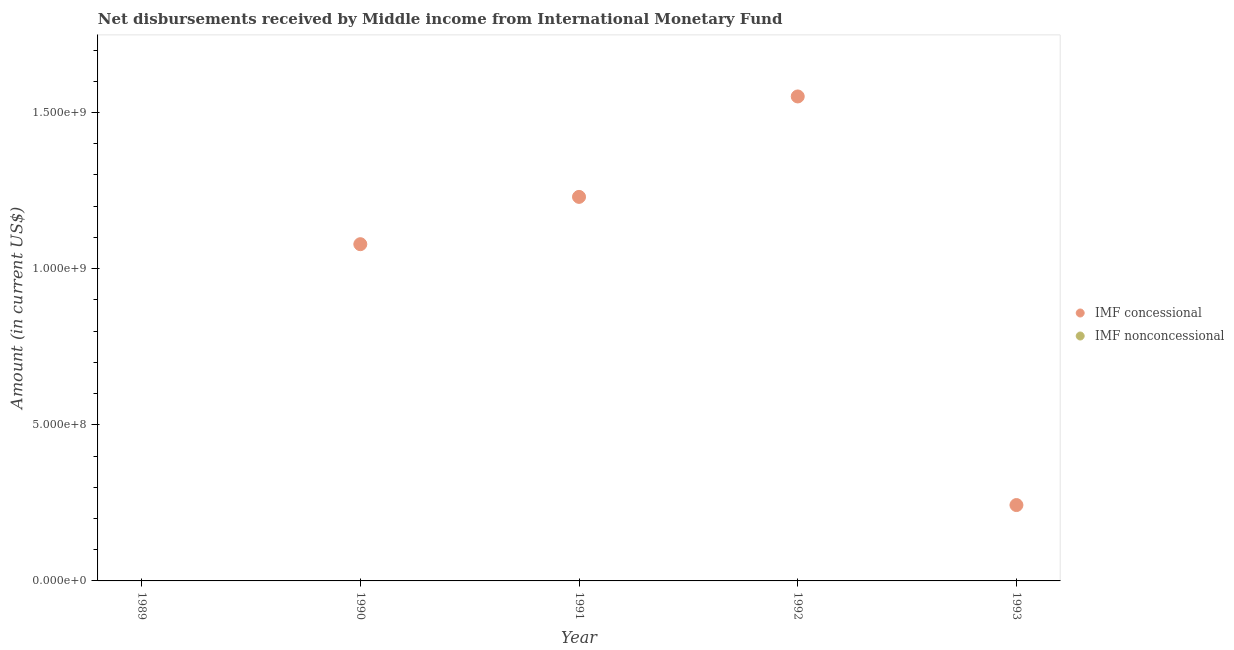Is the number of dotlines equal to the number of legend labels?
Offer a very short reply. No. What is the net non concessional disbursements from imf in 1989?
Your answer should be compact. 0. Across all years, what is the maximum net concessional disbursements from imf?
Provide a succinct answer. 1.55e+09. Across all years, what is the minimum net non concessional disbursements from imf?
Your response must be concise. 0. What is the total net concessional disbursements from imf in the graph?
Offer a terse response. 4.10e+09. What is the difference between the net concessional disbursements from imf in 1991 and that in 1992?
Provide a succinct answer. -3.22e+08. What is the difference between the net concessional disbursements from imf in 1993 and the net non concessional disbursements from imf in 1992?
Your response must be concise. 2.43e+08. What is the average net concessional disbursements from imf per year?
Ensure brevity in your answer.  8.20e+08. In how many years, is the net non concessional disbursements from imf greater than 200000000 US$?
Offer a terse response. 0. What is the ratio of the net concessional disbursements from imf in 1990 to that in 1993?
Give a very brief answer. 4.44. Is the net concessional disbursements from imf in 1992 less than that in 1993?
Your answer should be compact. No. What is the difference between the highest and the second highest net concessional disbursements from imf?
Give a very brief answer. 3.22e+08. What is the difference between the highest and the lowest net concessional disbursements from imf?
Offer a terse response. 1.55e+09. Does the net non concessional disbursements from imf monotonically increase over the years?
Ensure brevity in your answer.  No. What is the difference between two consecutive major ticks on the Y-axis?
Keep it short and to the point. 5.00e+08. Does the graph contain grids?
Your response must be concise. No. How are the legend labels stacked?
Your answer should be very brief. Vertical. What is the title of the graph?
Offer a terse response. Net disbursements received by Middle income from International Monetary Fund. Does "Total Population" appear as one of the legend labels in the graph?
Offer a very short reply. No. What is the Amount (in current US$) in IMF concessional in 1989?
Offer a terse response. 0. What is the Amount (in current US$) in IMF nonconcessional in 1989?
Give a very brief answer. 0. What is the Amount (in current US$) of IMF concessional in 1990?
Ensure brevity in your answer.  1.08e+09. What is the Amount (in current US$) in IMF concessional in 1991?
Keep it short and to the point. 1.23e+09. What is the Amount (in current US$) of IMF concessional in 1992?
Keep it short and to the point. 1.55e+09. What is the Amount (in current US$) of IMF concessional in 1993?
Provide a succinct answer. 2.43e+08. What is the Amount (in current US$) of IMF nonconcessional in 1993?
Provide a short and direct response. 0. Across all years, what is the maximum Amount (in current US$) of IMF concessional?
Provide a short and direct response. 1.55e+09. Across all years, what is the minimum Amount (in current US$) of IMF concessional?
Make the answer very short. 0. What is the total Amount (in current US$) of IMF concessional in the graph?
Your answer should be compact. 4.10e+09. What is the total Amount (in current US$) in IMF nonconcessional in the graph?
Offer a terse response. 0. What is the difference between the Amount (in current US$) of IMF concessional in 1990 and that in 1991?
Make the answer very short. -1.51e+08. What is the difference between the Amount (in current US$) in IMF concessional in 1990 and that in 1992?
Ensure brevity in your answer.  -4.73e+08. What is the difference between the Amount (in current US$) of IMF concessional in 1990 and that in 1993?
Your response must be concise. 8.35e+08. What is the difference between the Amount (in current US$) in IMF concessional in 1991 and that in 1992?
Your answer should be compact. -3.22e+08. What is the difference between the Amount (in current US$) in IMF concessional in 1991 and that in 1993?
Provide a short and direct response. 9.87e+08. What is the difference between the Amount (in current US$) in IMF concessional in 1992 and that in 1993?
Keep it short and to the point. 1.31e+09. What is the average Amount (in current US$) of IMF concessional per year?
Provide a succinct answer. 8.20e+08. What is the ratio of the Amount (in current US$) of IMF concessional in 1990 to that in 1991?
Give a very brief answer. 0.88. What is the ratio of the Amount (in current US$) of IMF concessional in 1990 to that in 1992?
Make the answer very short. 0.7. What is the ratio of the Amount (in current US$) of IMF concessional in 1990 to that in 1993?
Your answer should be very brief. 4.44. What is the ratio of the Amount (in current US$) in IMF concessional in 1991 to that in 1992?
Provide a short and direct response. 0.79. What is the ratio of the Amount (in current US$) of IMF concessional in 1991 to that in 1993?
Your answer should be compact. 5.06. What is the ratio of the Amount (in current US$) in IMF concessional in 1992 to that in 1993?
Ensure brevity in your answer.  6.39. What is the difference between the highest and the second highest Amount (in current US$) of IMF concessional?
Provide a succinct answer. 3.22e+08. What is the difference between the highest and the lowest Amount (in current US$) in IMF concessional?
Offer a terse response. 1.55e+09. 